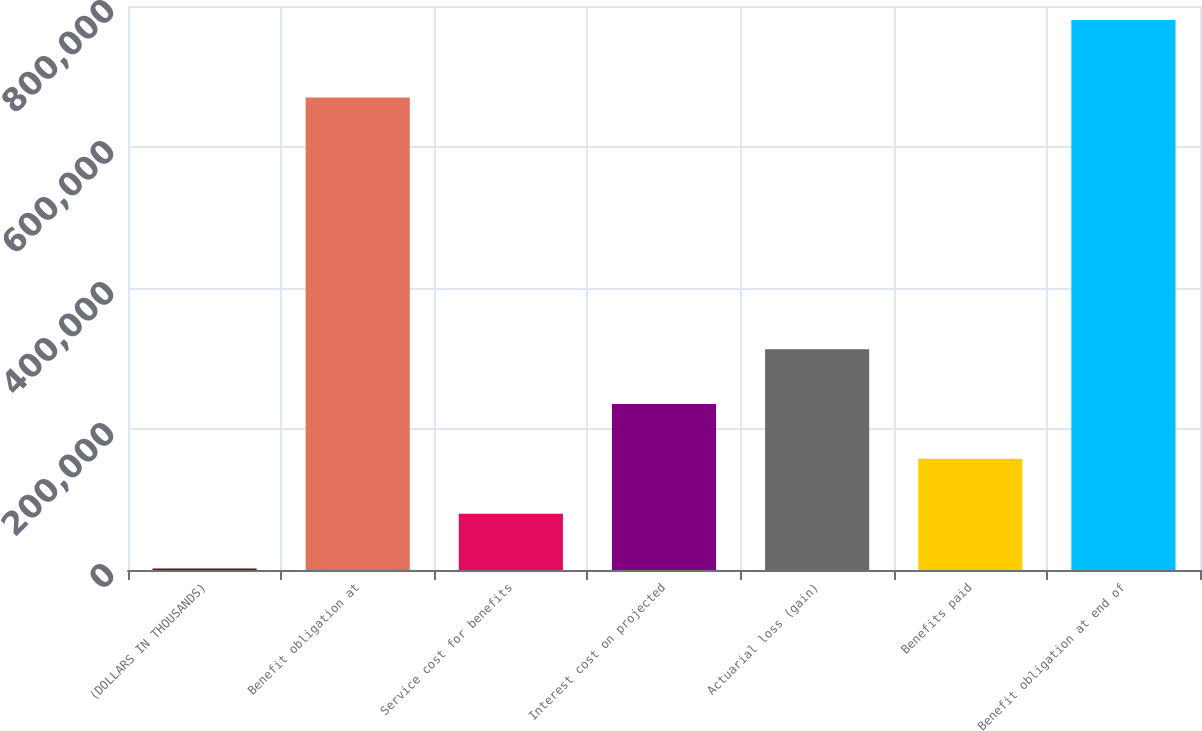Convert chart to OTSL. <chart><loc_0><loc_0><loc_500><loc_500><bar_chart><fcel>(DOLLARS IN THOUSANDS)<fcel>Benefit obligation at<fcel>Service cost for benefits<fcel>Interest cost on projected<fcel>Actuarial loss (gain)<fcel>Benefits paid<fcel>Benefit obligation at end of<nl><fcel>2012<fcel>670231<fcel>79827.2<fcel>235458<fcel>313273<fcel>157642<fcel>780164<nl></chart> 